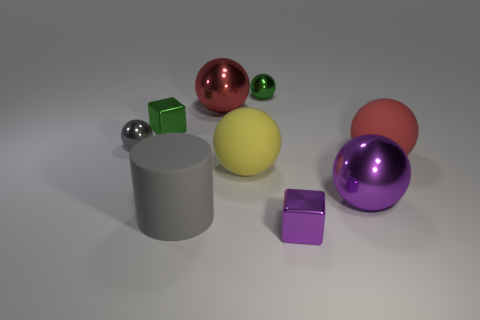Do the large metallic thing behind the small gray thing and the purple thing that is behind the small purple block have the same shape?
Offer a terse response. Yes. How many objects are purple things that are to the left of the purple sphere or gray shiny cubes?
Offer a terse response. 1. There is a small thing that is the same color as the big matte cylinder; what is it made of?
Your answer should be compact. Metal. Are there any gray spheres that are left of the cube that is left of the cube on the right side of the tiny green metal ball?
Your answer should be compact. Yes. Are there fewer tiny metallic spheres that are right of the gray rubber cylinder than big shiny balls behind the big yellow thing?
Provide a short and direct response. No. There is a small sphere that is the same material as the tiny gray thing; what color is it?
Offer a terse response. Green. There is a big metal object in front of the large red sphere right of the large yellow rubber sphere; what color is it?
Your answer should be very brief. Purple. Is there a sphere of the same color as the cylinder?
Keep it short and to the point. Yes. What shape is the gray metal thing that is the same size as the purple metallic cube?
Your response must be concise. Sphere. There is a small ball that is left of the cylinder; how many large purple objects are right of it?
Your answer should be very brief. 1. 